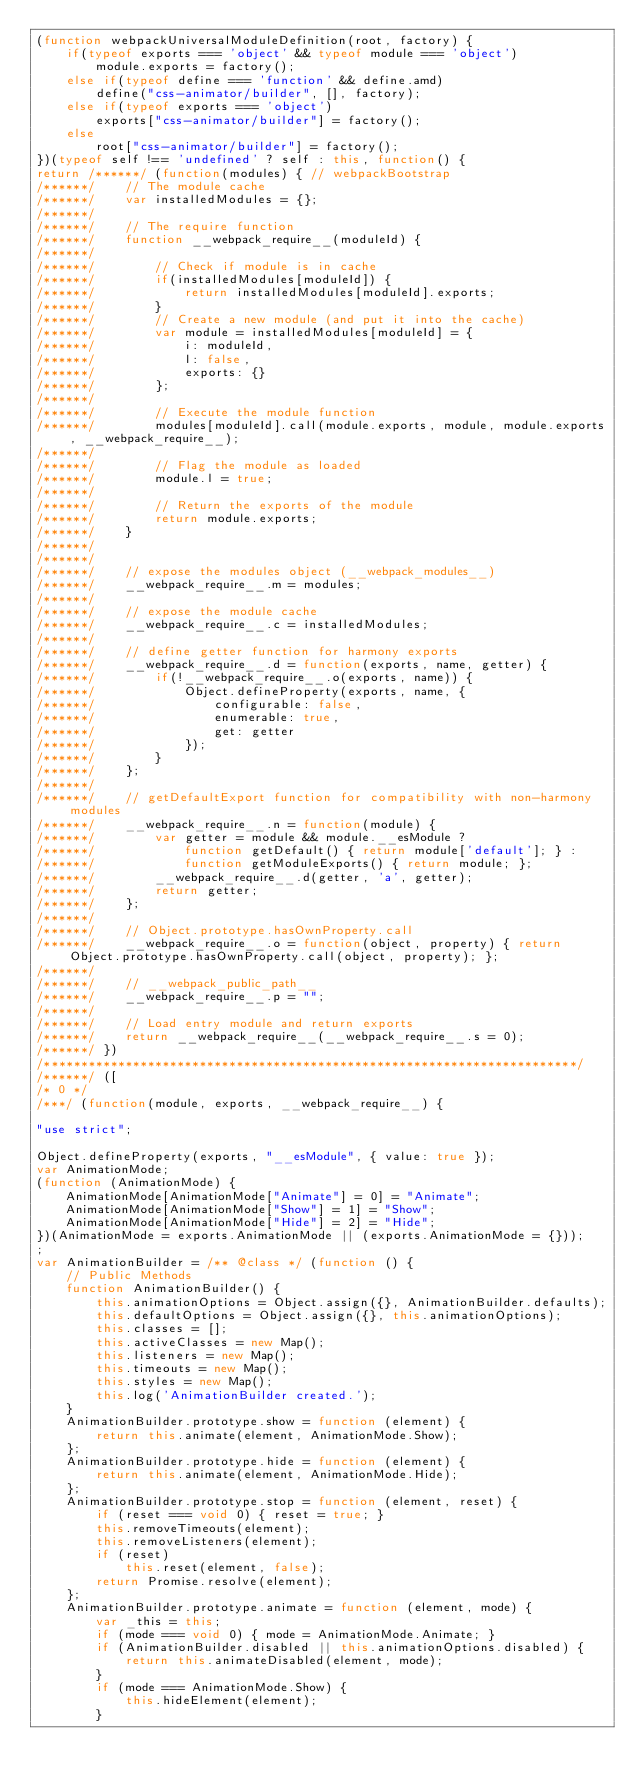Convert code to text. <code><loc_0><loc_0><loc_500><loc_500><_JavaScript_>(function webpackUniversalModuleDefinition(root, factory) {
	if(typeof exports === 'object' && typeof module === 'object')
		module.exports = factory();
	else if(typeof define === 'function' && define.amd)
		define("css-animator/builder", [], factory);
	else if(typeof exports === 'object')
		exports["css-animator/builder"] = factory();
	else
		root["css-animator/builder"] = factory();
})(typeof self !== 'undefined' ? self : this, function() {
return /******/ (function(modules) { // webpackBootstrap
/******/ 	// The module cache
/******/ 	var installedModules = {};
/******/
/******/ 	// The require function
/******/ 	function __webpack_require__(moduleId) {
/******/
/******/ 		// Check if module is in cache
/******/ 		if(installedModules[moduleId]) {
/******/ 			return installedModules[moduleId].exports;
/******/ 		}
/******/ 		// Create a new module (and put it into the cache)
/******/ 		var module = installedModules[moduleId] = {
/******/ 			i: moduleId,
/******/ 			l: false,
/******/ 			exports: {}
/******/ 		};
/******/
/******/ 		// Execute the module function
/******/ 		modules[moduleId].call(module.exports, module, module.exports, __webpack_require__);
/******/
/******/ 		// Flag the module as loaded
/******/ 		module.l = true;
/******/
/******/ 		// Return the exports of the module
/******/ 		return module.exports;
/******/ 	}
/******/
/******/
/******/ 	// expose the modules object (__webpack_modules__)
/******/ 	__webpack_require__.m = modules;
/******/
/******/ 	// expose the module cache
/******/ 	__webpack_require__.c = installedModules;
/******/
/******/ 	// define getter function for harmony exports
/******/ 	__webpack_require__.d = function(exports, name, getter) {
/******/ 		if(!__webpack_require__.o(exports, name)) {
/******/ 			Object.defineProperty(exports, name, {
/******/ 				configurable: false,
/******/ 				enumerable: true,
/******/ 				get: getter
/******/ 			});
/******/ 		}
/******/ 	};
/******/
/******/ 	// getDefaultExport function for compatibility with non-harmony modules
/******/ 	__webpack_require__.n = function(module) {
/******/ 		var getter = module && module.__esModule ?
/******/ 			function getDefault() { return module['default']; } :
/******/ 			function getModuleExports() { return module; };
/******/ 		__webpack_require__.d(getter, 'a', getter);
/******/ 		return getter;
/******/ 	};
/******/
/******/ 	// Object.prototype.hasOwnProperty.call
/******/ 	__webpack_require__.o = function(object, property) { return Object.prototype.hasOwnProperty.call(object, property); };
/******/
/******/ 	// __webpack_public_path__
/******/ 	__webpack_require__.p = "";
/******/
/******/ 	// Load entry module and return exports
/******/ 	return __webpack_require__(__webpack_require__.s = 0);
/******/ })
/************************************************************************/
/******/ ([
/* 0 */
/***/ (function(module, exports, __webpack_require__) {

"use strict";

Object.defineProperty(exports, "__esModule", { value: true });
var AnimationMode;
(function (AnimationMode) {
    AnimationMode[AnimationMode["Animate"] = 0] = "Animate";
    AnimationMode[AnimationMode["Show"] = 1] = "Show";
    AnimationMode[AnimationMode["Hide"] = 2] = "Hide";
})(AnimationMode = exports.AnimationMode || (exports.AnimationMode = {}));
;
var AnimationBuilder = /** @class */ (function () {
    // Public Methods
    function AnimationBuilder() {
        this.animationOptions = Object.assign({}, AnimationBuilder.defaults);
        this.defaultOptions = Object.assign({}, this.animationOptions);
        this.classes = [];
        this.activeClasses = new Map();
        this.listeners = new Map();
        this.timeouts = new Map();
        this.styles = new Map();
        this.log('AnimationBuilder created.');
    }
    AnimationBuilder.prototype.show = function (element) {
        return this.animate(element, AnimationMode.Show);
    };
    AnimationBuilder.prototype.hide = function (element) {
        return this.animate(element, AnimationMode.Hide);
    };
    AnimationBuilder.prototype.stop = function (element, reset) {
        if (reset === void 0) { reset = true; }
        this.removeTimeouts(element);
        this.removeListeners(element);
        if (reset)
            this.reset(element, false);
        return Promise.resolve(element);
    };
    AnimationBuilder.prototype.animate = function (element, mode) {
        var _this = this;
        if (mode === void 0) { mode = AnimationMode.Animate; }
        if (AnimationBuilder.disabled || this.animationOptions.disabled) {
            return this.animateDisabled(element, mode);
        }
        if (mode === AnimationMode.Show) {
            this.hideElement(element);
        }</code> 